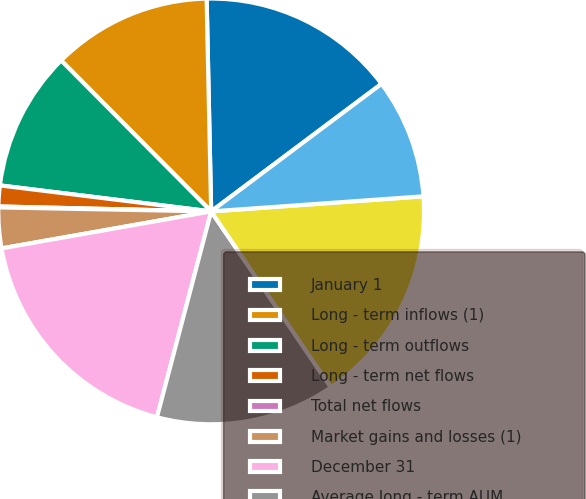Convert chart to OTSL. <chart><loc_0><loc_0><loc_500><loc_500><pie_chart><fcel>January 1<fcel>Long - term inflows (1)<fcel>Long - term outflows<fcel>Long - term net flows<fcel>Total net flows<fcel>Market gains and losses (1)<fcel>December 31<fcel>Average long - term AUM<fcel>Average AUM<fcel>Gross revenue yield on AUM (2)<nl><fcel>15.11%<fcel>12.11%<fcel>10.6%<fcel>1.58%<fcel>0.07%<fcel>3.08%<fcel>18.12%<fcel>13.61%<fcel>16.62%<fcel>9.1%<nl></chart> 